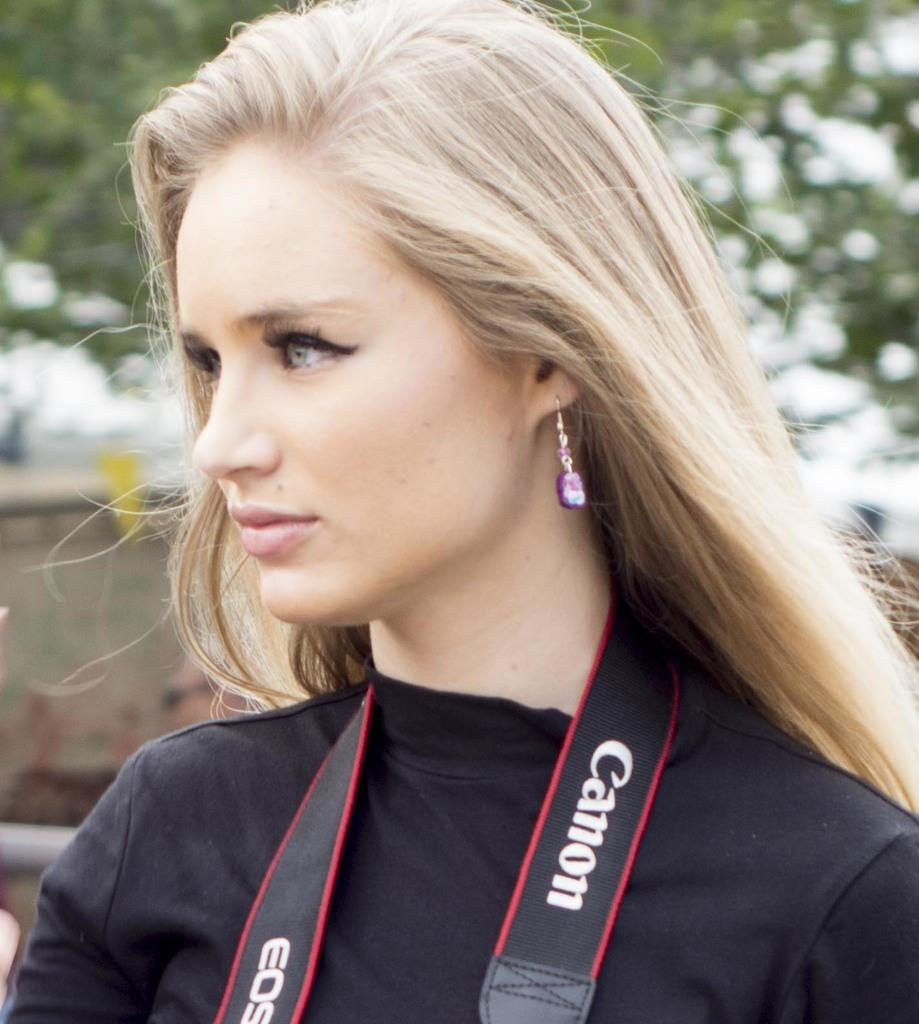What is the main subject of the picture? There is a close-up image of a woman in the picture. What can be seen on the woman's body? The woman is wearing clothes and earrings. What accessory is visible around her neck? There is a camera visible around her neck. How would you describe the background of the image? The background of the image is blurred. What type of oatmeal is the woman eating in the image? There is no oatmeal present in the image; the woman is not eating anything. Can you tell me about the woman's father in the image? There is no information about the woman's father in the image. 